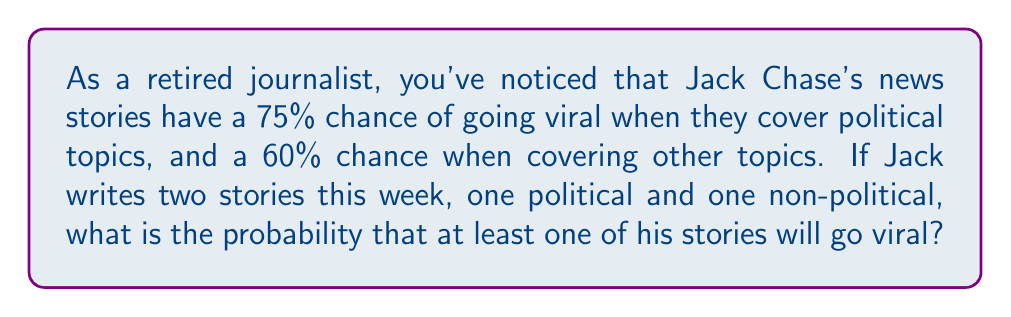What is the answer to this math problem? Let's approach this step-by-step:

1) First, let's define our events:
   A: Political story goes viral
   B: Non-political story goes viral

2) We're given:
   P(A) = 0.75
   P(B) = 0.60

3) We want to find the probability that at least one story goes viral. It's easier to calculate the probability that neither story goes viral and then subtract from 1.

4) Probability that the political story doesn't go viral:
   P(not A) = 1 - P(A) = 1 - 0.75 = 0.25

5) Probability that the non-political story doesn't go viral:
   P(not B) = 1 - P(B) = 1 - 0.60 = 0.40

6) Probability that neither story goes viral:
   P(neither) = P(not A) × P(not B) = 0.25 × 0.40 = 0.10

7) Therefore, the probability that at least one story goes viral:
   P(at least one) = 1 - P(neither) = 1 - 0.10 = 0.90

8) We can express this as a percentage:
   0.90 × 100% = 90%
Answer: 90% 